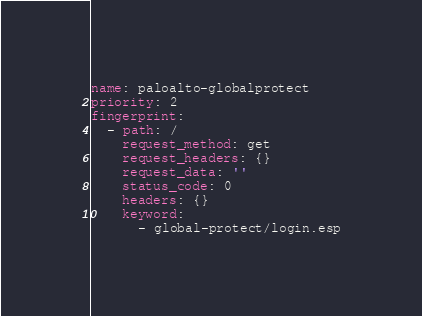<code> <loc_0><loc_0><loc_500><loc_500><_YAML_>name: paloalto-globalprotect
priority: 2
fingerprint:
  - path: /
    request_method: get
    request_headers: {}
    request_data: ''
    status_code: 0
    headers: {}
    keyword:
      - global-protect/login.esp
</code> 